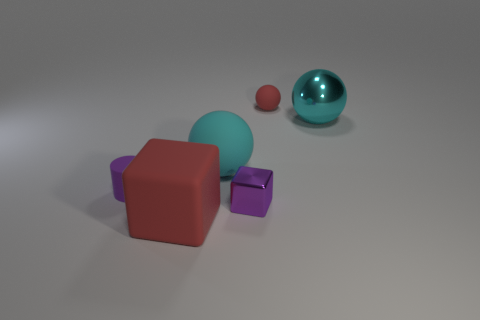What shapes can be seen in the image? The image features a variety of geometric shapes including a cube, a sphere, and what appears to be a smaller cube or rectangular prism. 